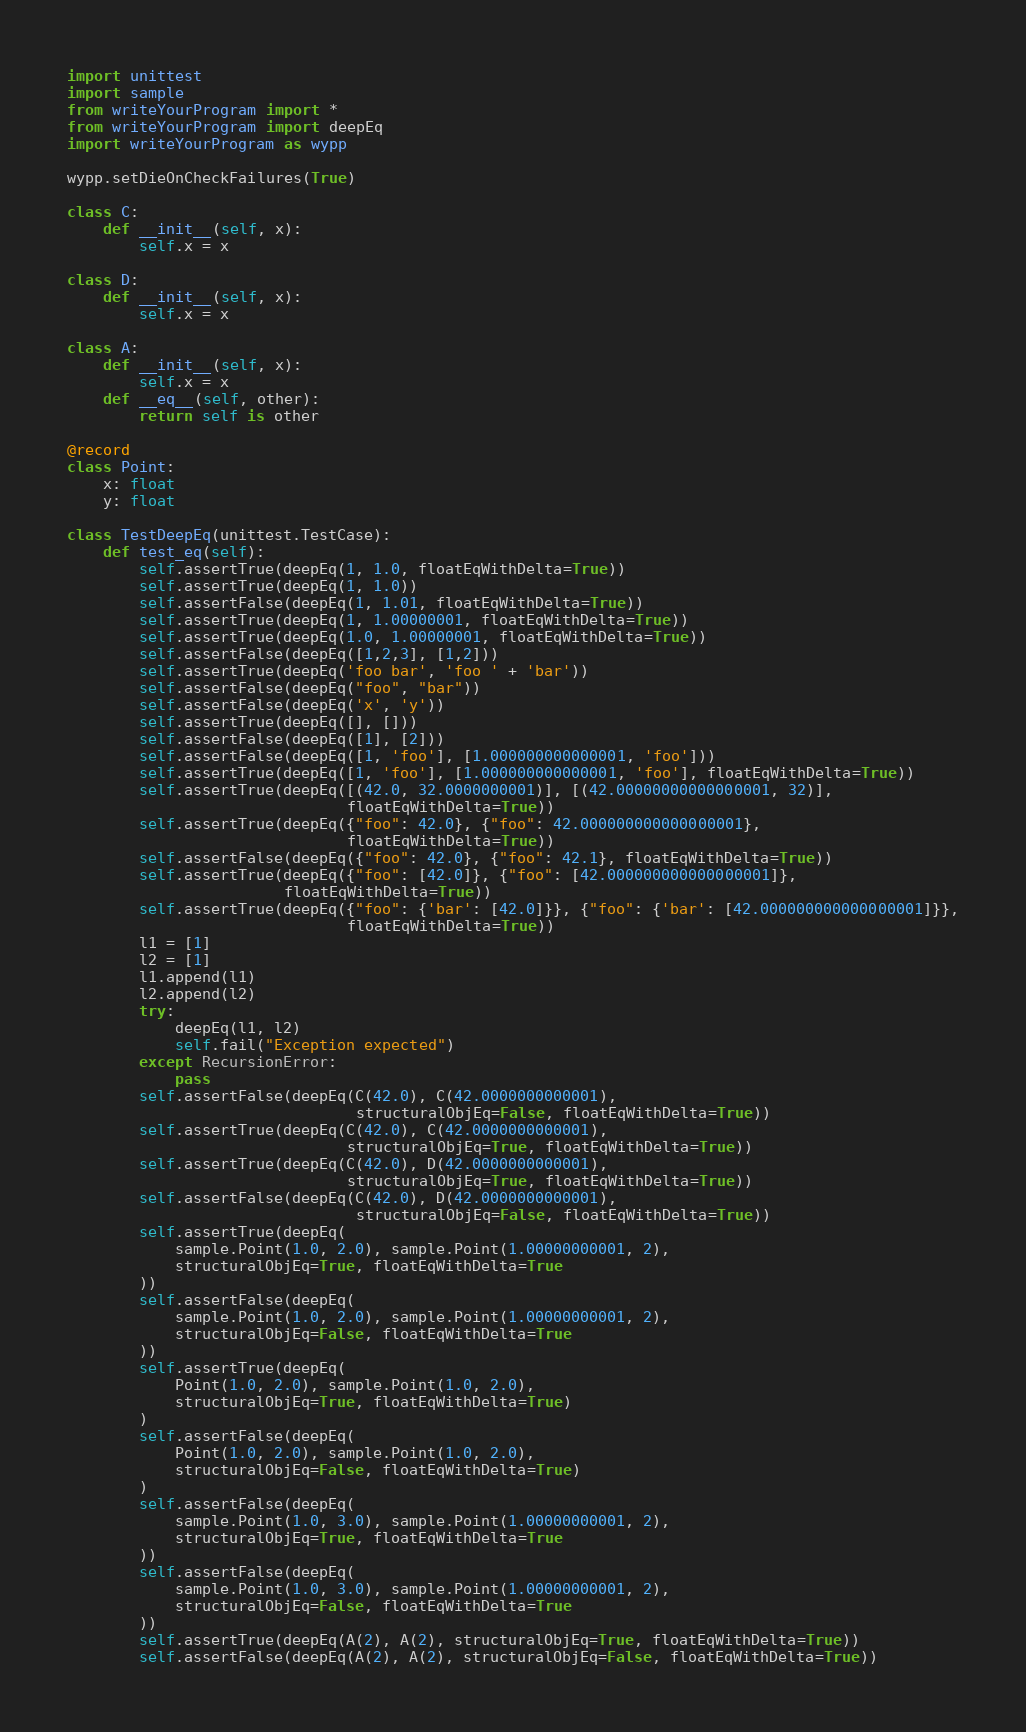Convert code to text. <code><loc_0><loc_0><loc_500><loc_500><_Python_>import unittest
import sample
from writeYourProgram import *
from writeYourProgram import deepEq
import writeYourProgram as wypp

wypp.setDieOnCheckFailures(True)

class C:
    def __init__(self, x):
        self.x = x

class D:
    def __init__(self, x):
        self.x = x

class A:
    def __init__(self, x):
        self.x = x
    def __eq__(self, other):
        return self is other

@record
class Point:
    x: float
    y: float

class TestDeepEq(unittest.TestCase):
    def test_eq(self):
        self.assertTrue(deepEq(1, 1.0, floatEqWithDelta=True))
        self.assertTrue(deepEq(1, 1.0))
        self.assertFalse(deepEq(1, 1.01, floatEqWithDelta=True))
        self.assertTrue(deepEq(1, 1.00000001, floatEqWithDelta=True))
        self.assertTrue(deepEq(1.0, 1.00000001, floatEqWithDelta=True))
        self.assertFalse(deepEq([1,2,3], [1,2]))
        self.assertTrue(deepEq('foo bar', 'foo ' + 'bar'))
        self.assertFalse(deepEq("foo", "bar"))
        self.assertFalse(deepEq('x', 'y'))
        self.assertTrue(deepEq([], []))
        self.assertFalse(deepEq([1], [2]))
        self.assertFalse(deepEq([1, 'foo'], [1.000000000000001, 'foo']))
        self.assertTrue(deepEq([1, 'foo'], [1.000000000000001, 'foo'], floatEqWithDelta=True))
        self.assertTrue(deepEq([(42.0, 32.0000000001)], [(42.00000000000000001, 32)],
                               floatEqWithDelta=True))
        self.assertTrue(deepEq({"foo": 42.0}, {"foo": 42.000000000000000001},
                               floatEqWithDelta=True))
        self.assertFalse(deepEq({"foo": 42.0}, {"foo": 42.1}, floatEqWithDelta=True))
        self.assertTrue(deepEq({"foo": [42.0]}, {"foo": [42.000000000000000001]},
                        floatEqWithDelta=True))
        self.assertTrue(deepEq({"foo": {'bar': [42.0]}}, {"foo": {'bar': [42.000000000000000001]}},
                               floatEqWithDelta=True))
        l1 = [1]
        l2 = [1]
        l1.append(l1)
        l2.append(l2)
        try:
            deepEq(l1, l2)
            self.fail("Exception expected")
        except RecursionError:
            pass
        self.assertFalse(deepEq(C(42.0), C(42.0000000000001),
                                structuralObjEq=False, floatEqWithDelta=True))
        self.assertTrue(deepEq(C(42.0), C(42.0000000000001),
                               structuralObjEq=True, floatEqWithDelta=True))
        self.assertTrue(deepEq(C(42.0), D(42.0000000000001),
                               structuralObjEq=True, floatEqWithDelta=True))
        self.assertFalse(deepEq(C(42.0), D(42.0000000000001),
                                structuralObjEq=False, floatEqWithDelta=True))
        self.assertTrue(deepEq(
            sample.Point(1.0, 2.0), sample.Point(1.00000000001, 2),
            structuralObjEq=True, floatEqWithDelta=True
        ))
        self.assertFalse(deepEq(
            sample.Point(1.0, 2.0), sample.Point(1.00000000001, 2),
            structuralObjEq=False, floatEqWithDelta=True
        ))
        self.assertTrue(deepEq(
            Point(1.0, 2.0), sample.Point(1.0, 2.0),
            structuralObjEq=True, floatEqWithDelta=True)
        )
        self.assertFalse(deepEq(
            Point(1.0, 2.0), sample.Point(1.0, 2.0),
            structuralObjEq=False, floatEqWithDelta=True)
        )
        self.assertFalse(deepEq(
            sample.Point(1.0, 3.0), sample.Point(1.00000000001, 2),
            structuralObjEq=True, floatEqWithDelta=True
        ))
        self.assertFalse(deepEq(
            sample.Point(1.0, 3.0), sample.Point(1.00000000001, 2),
            structuralObjEq=False, floatEqWithDelta=True
        ))
        self.assertTrue(deepEq(A(2), A(2), structuralObjEq=True, floatEqWithDelta=True))
        self.assertFalse(deepEq(A(2), A(2), structuralObjEq=False, floatEqWithDelta=True))
</code> 